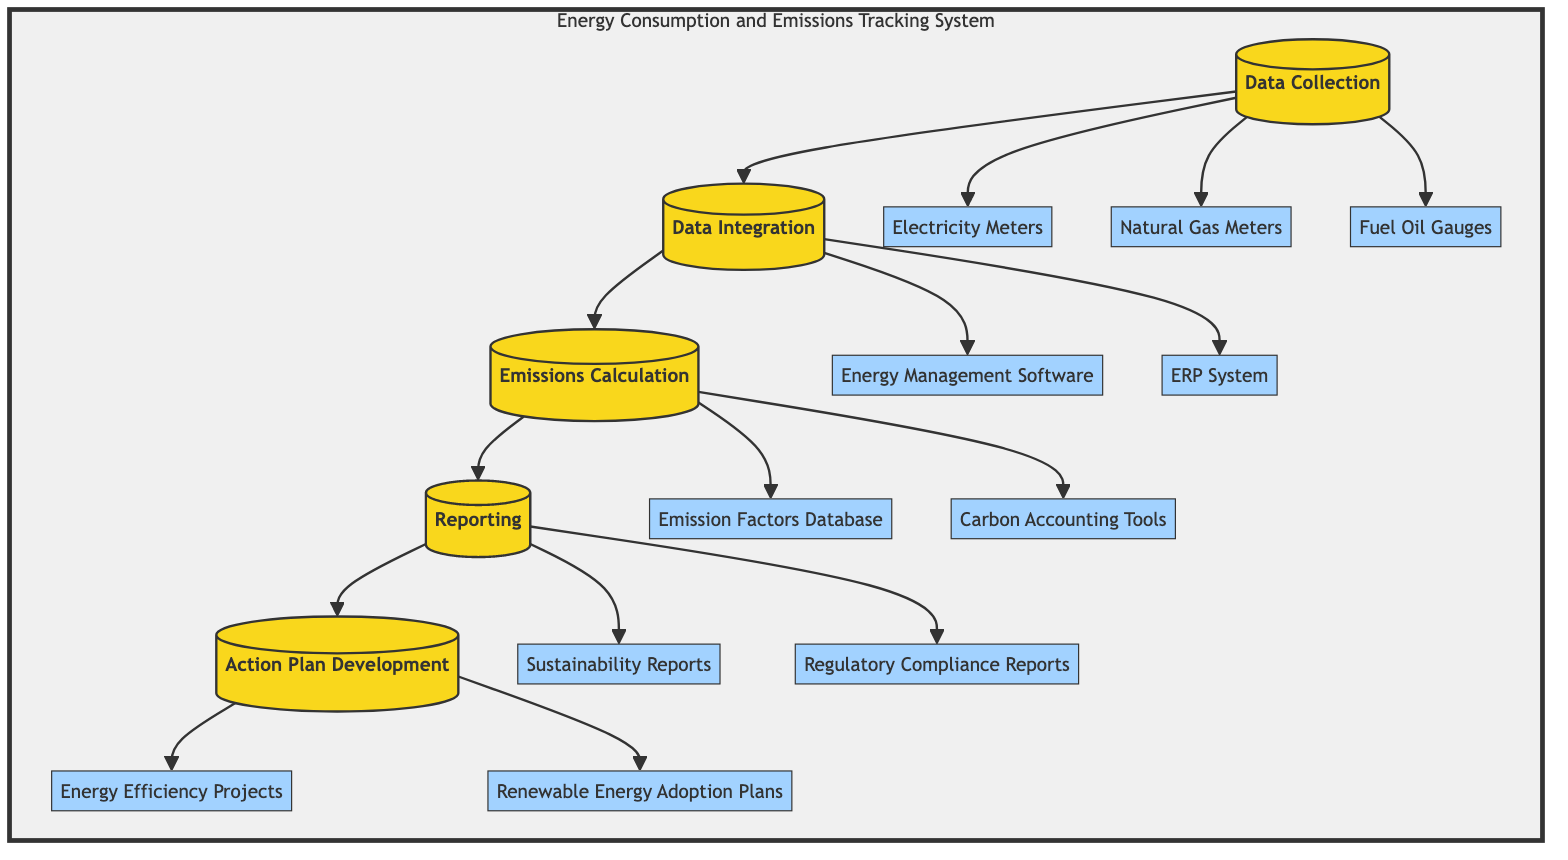What is the first step in the flow chart? The first step in the flow chart is "Data Collection", as indicated at the start of the sequence of processes outlined in the diagram.
Answer: Data Collection How many entities are linked to the Data Collection step? The Data Collection step is linked to three entities: Electricity Meters, Natural Gas Meters, and Fuel Oil Gauges.
Answer: Three What step comes after Data Integration? The step that comes after Data Integration is "Emissions Calculation," which follows directly in the flow of the diagram.
Answer: Emissions Calculation Which two reports are generated in the Reporting step? The Reporting step generates two types of reports: Sustainability Reports and Regulatory Compliance Reports. These are specifically listed under the Reporting node in the diagram.
Answer: Sustainability Reports, Regulatory Compliance Reports What is the last process in the system? The last process in the Energy Consumption and Emissions Tracking System is "Action Plan Development," completing the flow as indicated in the diagram.
Answer: Action Plan Development What is the relationship between Emissions Calculation and Reporting? The relationship is sequential; Emissions Calculation must be completed before moving on to Reporting, as indicated by the flow direction in the diagram.
Answer: Sequential What entities are associated with Action Plan Development? Action Plan Development is associated with two entities: Energy Efficiency Projects and Renewable Energy Adoption Plans, both listed as connected to this step in the diagram.
Answer: Energy Efficiency Projects, Renewable Energy Adoption Plans How many steps are in the Energy Consumption and Emissions Tracking System? There are five steps in the Energy Consumption and Emissions Tracking System, as outlined directly in the flow chart.
Answer: Five 